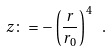<formula> <loc_0><loc_0><loc_500><loc_500>z \colon = - \left ( \frac { r } { r _ { 0 } } \right ) ^ { 4 } \ .</formula> 